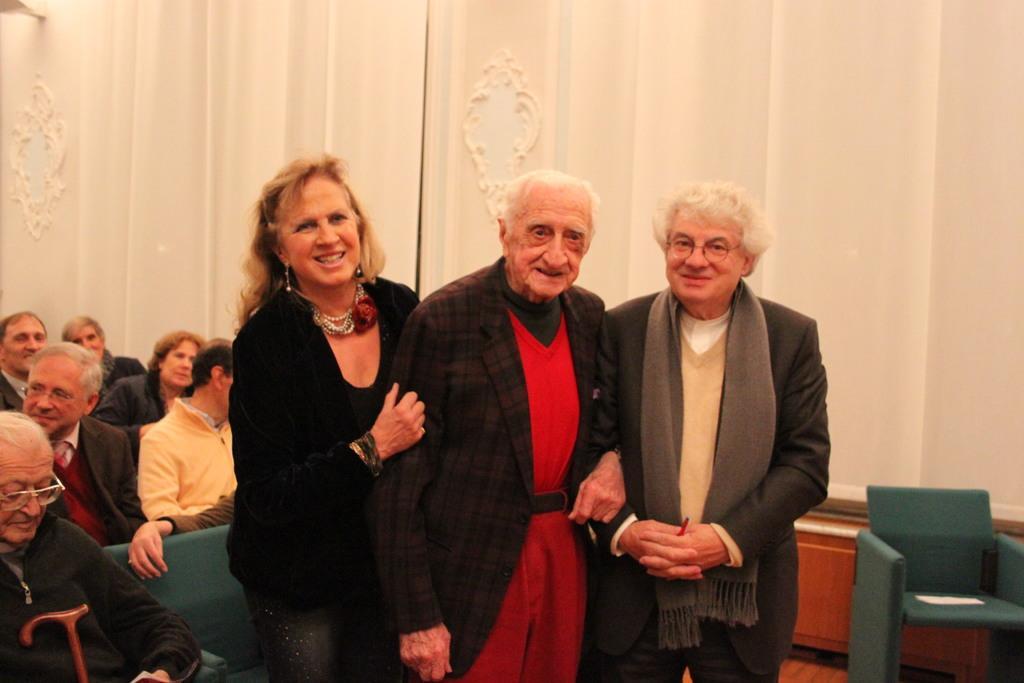Please provide a concise description of this image. This picture describes about group of people, few people are seated and few are standing, in the background we can see a wall and a light. 